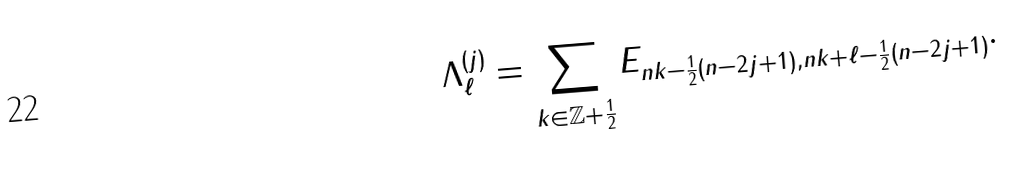<formula> <loc_0><loc_0><loc_500><loc_500>\Lambda ^ { ( j ) } _ { \ell } = \sum _ { k \in \mathbb { Z } + \frac { 1 } { 2 } } E _ { n k - \frac { 1 } { 2 } ( n - 2 j + 1 ) , n { k + \ell } - \frac { 1 } { 2 } ( n - 2 j + 1 ) } .</formula> 